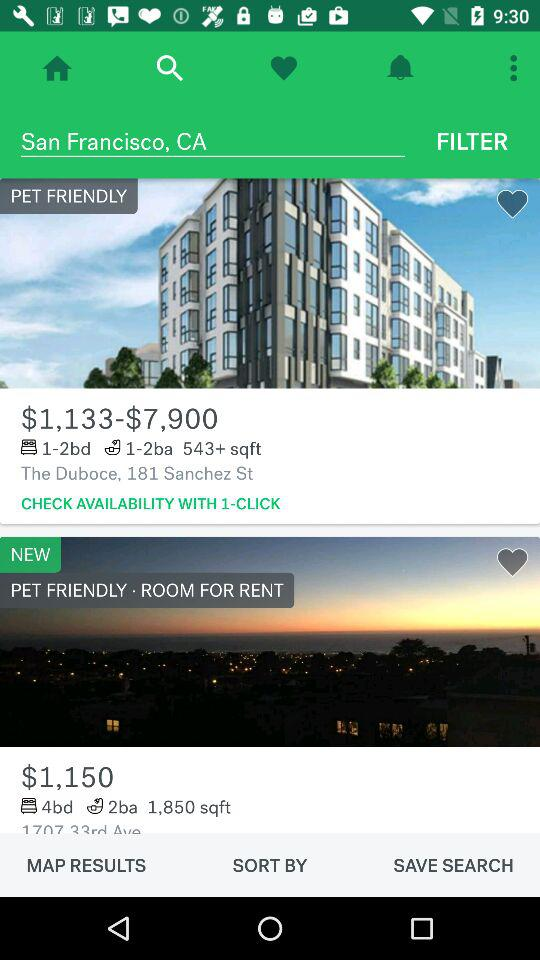How many square feet are there for the apartment having 1-2 bed range? For the apartment having 1-2 bed range, there are more than 543 square feet of area. 